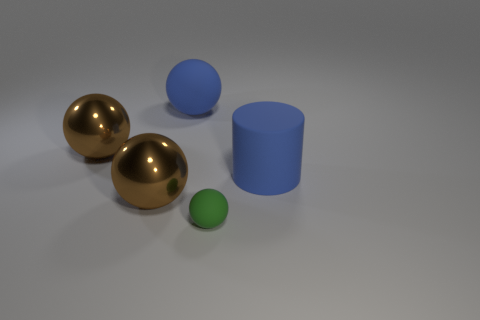Can you describe the lighting in the scene? The lighting in the scene is soft and diffused, casting subtle shadows beneath the objects without creating harsh highlights, suggesting an evenly lit environment. 